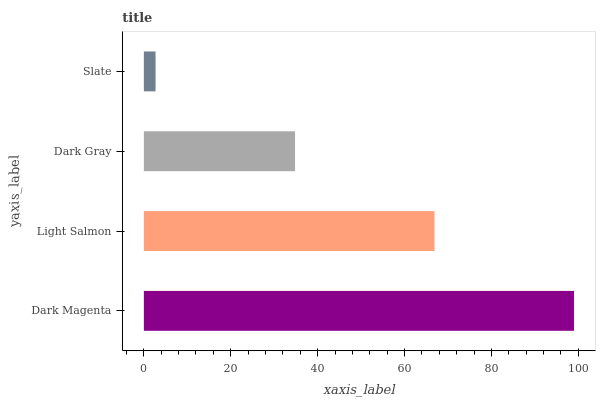Is Slate the minimum?
Answer yes or no. Yes. Is Dark Magenta the maximum?
Answer yes or no. Yes. Is Light Salmon the minimum?
Answer yes or no. No. Is Light Salmon the maximum?
Answer yes or no. No. Is Dark Magenta greater than Light Salmon?
Answer yes or no. Yes. Is Light Salmon less than Dark Magenta?
Answer yes or no. Yes. Is Light Salmon greater than Dark Magenta?
Answer yes or no. No. Is Dark Magenta less than Light Salmon?
Answer yes or no. No. Is Light Salmon the high median?
Answer yes or no. Yes. Is Dark Gray the low median?
Answer yes or no. Yes. Is Dark Magenta the high median?
Answer yes or no. No. Is Slate the low median?
Answer yes or no. No. 